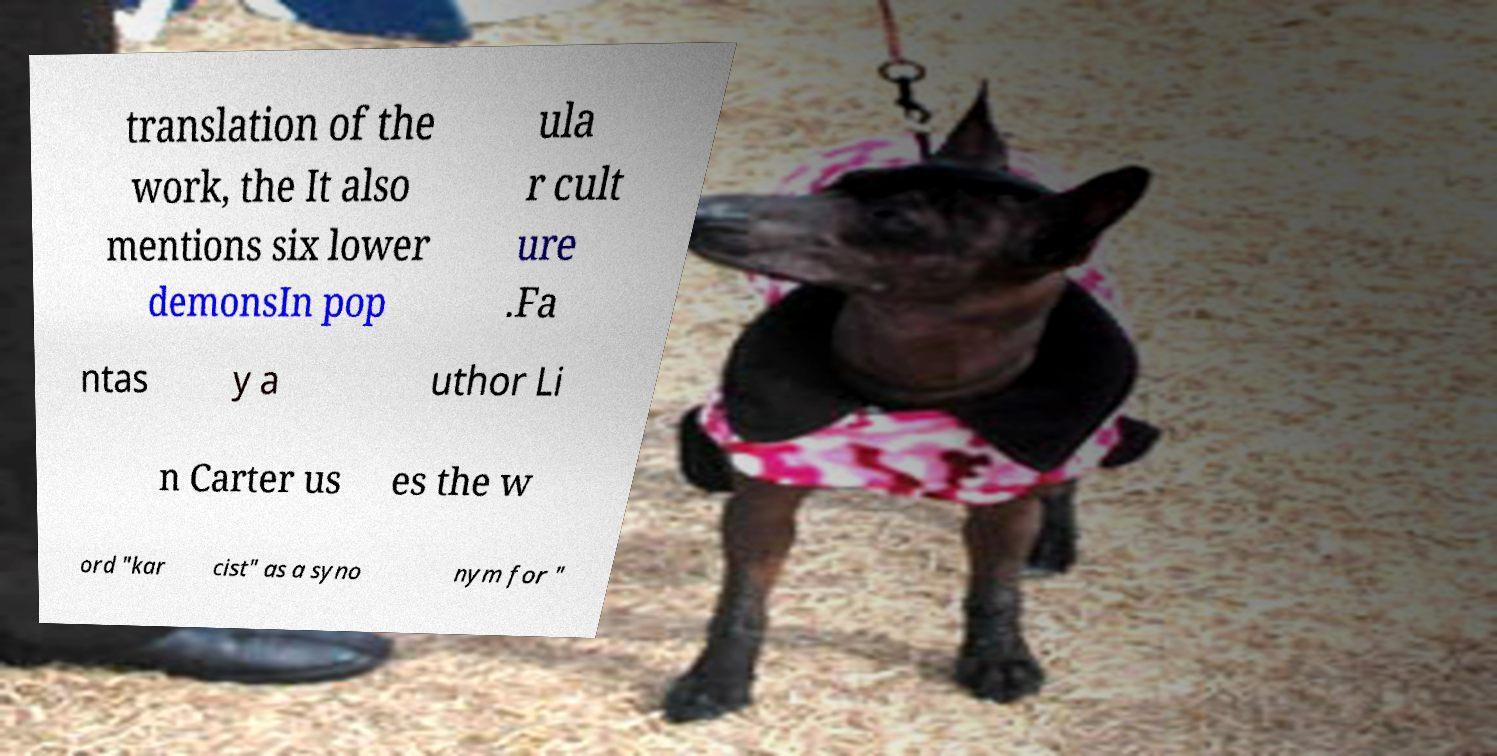Can you accurately transcribe the text from the provided image for me? translation of the work, the It also mentions six lower demonsIn pop ula r cult ure .Fa ntas y a uthor Li n Carter us es the w ord "kar cist" as a syno nym for " 